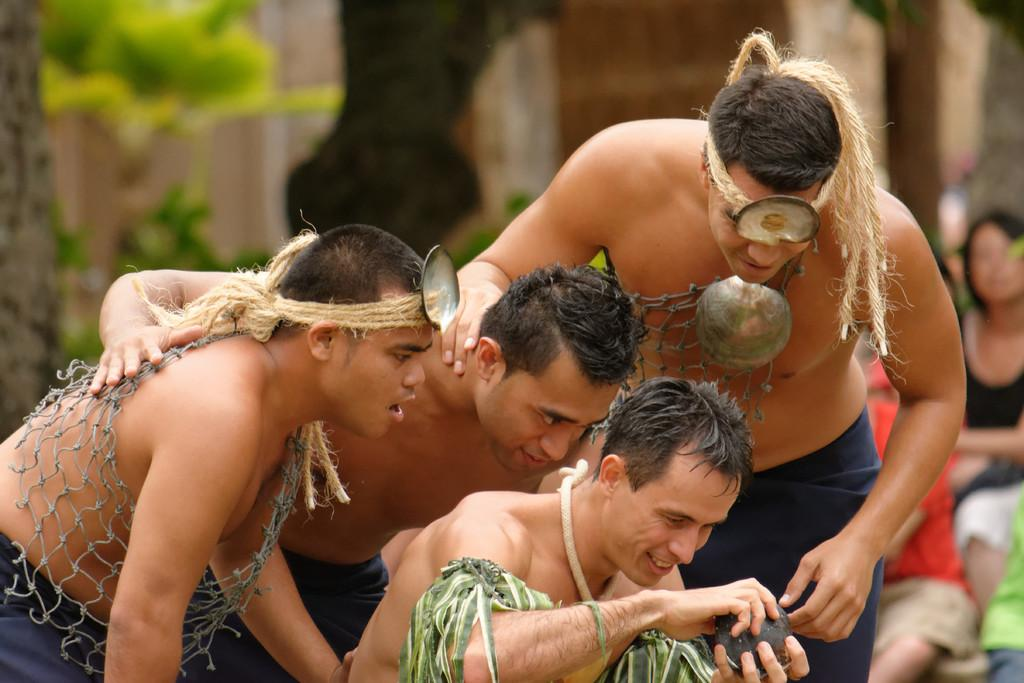How many boys are in the image? There are four boys in the image. What are the boys wearing in the image? The boys are shirtless in the image. What are the boys doing in the image? The boys are sitting down and looking at a stone in the image. Who is holding the stone in the image? The front boy is holding the stone in the image. Can you describe the background of the image? The background of the image is blurred. What type of house can be seen in the background of the image? There is no house visible in the background of the image; it is blurred. How many fingers does the boy on the right have in the image? The provided facts do not mention the number of fingers on the boys' hands, so it cannot be determined from the image. 